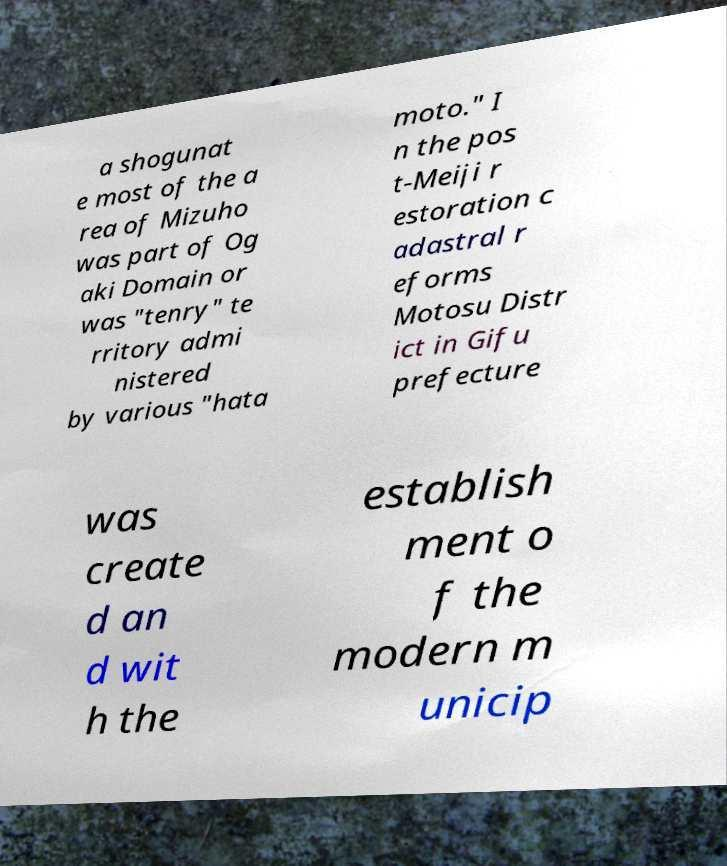Please read and relay the text visible in this image. What does it say? a shogunat e most of the a rea of Mizuho was part of Og aki Domain or was "tenry" te rritory admi nistered by various "hata moto." I n the pos t-Meiji r estoration c adastral r eforms Motosu Distr ict in Gifu prefecture was create d an d wit h the establish ment o f the modern m unicip 